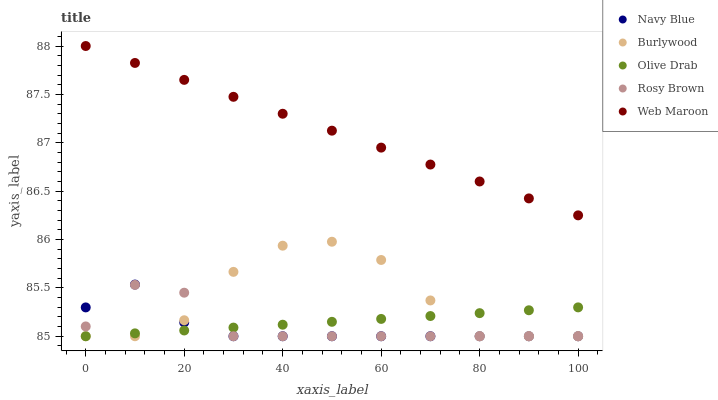Does Navy Blue have the minimum area under the curve?
Answer yes or no. Yes. Does Web Maroon have the maximum area under the curve?
Answer yes or no. Yes. Does Rosy Brown have the minimum area under the curve?
Answer yes or no. No. Does Rosy Brown have the maximum area under the curve?
Answer yes or no. No. Is Olive Drab the smoothest?
Answer yes or no. Yes. Is Burlywood the roughest?
Answer yes or no. Yes. Is Navy Blue the smoothest?
Answer yes or no. No. Is Navy Blue the roughest?
Answer yes or no. No. Does Burlywood have the lowest value?
Answer yes or no. Yes. Does Web Maroon have the lowest value?
Answer yes or no. No. Does Web Maroon have the highest value?
Answer yes or no. Yes. Does Navy Blue have the highest value?
Answer yes or no. No. Is Burlywood less than Web Maroon?
Answer yes or no. Yes. Is Web Maroon greater than Rosy Brown?
Answer yes or no. Yes. Does Olive Drab intersect Navy Blue?
Answer yes or no. Yes. Is Olive Drab less than Navy Blue?
Answer yes or no. No. Is Olive Drab greater than Navy Blue?
Answer yes or no. No. Does Burlywood intersect Web Maroon?
Answer yes or no. No. 